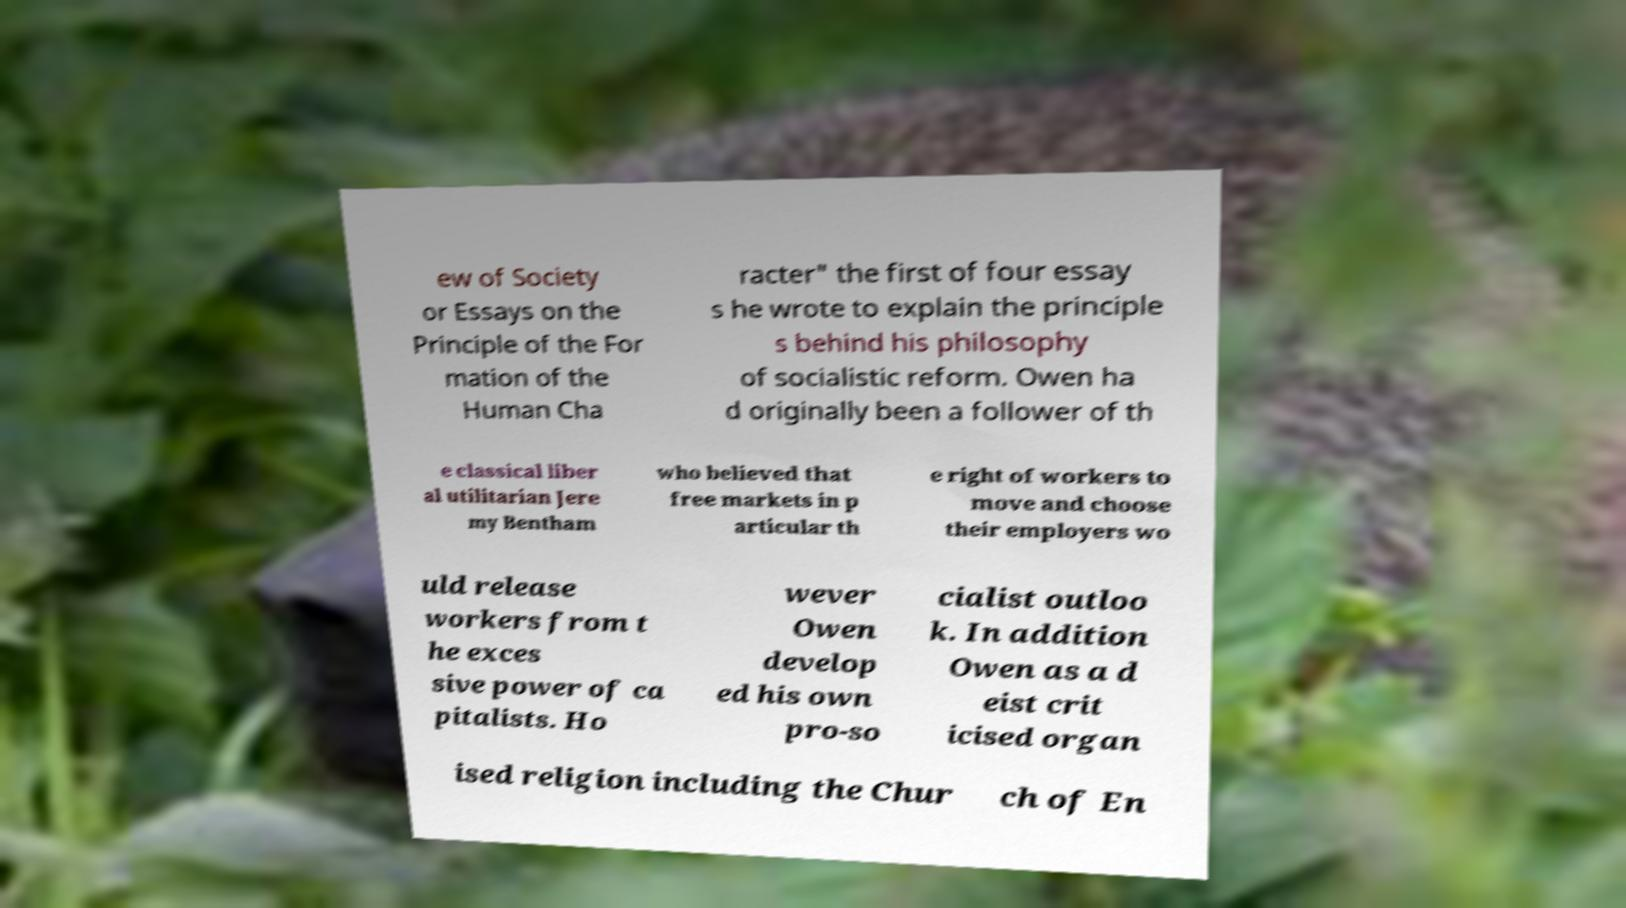Can you read and provide the text displayed in the image?This photo seems to have some interesting text. Can you extract and type it out for me? ew of Society or Essays on the Principle of the For mation of the Human Cha racter" the first of four essay s he wrote to explain the principle s behind his philosophy of socialistic reform. Owen ha d originally been a follower of th e classical liber al utilitarian Jere my Bentham who believed that free markets in p articular th e right of workers to move and choose their employers wo uld release workers from t he exces sive power of ca pitalists. Ho wever Owen develop ed his own pro-so cialist outloo k. In addition Owen as a d eist crit icised organ ised religion including the Chur ch of En 